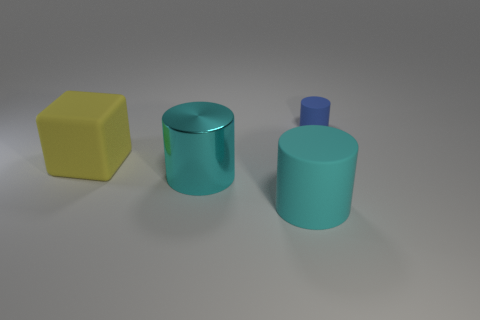Add 2 rubber cylinders. How many objects exist? 6 Subtract all cubes. How many objects are left? 3 Subtract all large cyan matte cylinders. Subtract all big cyan shiny cylinders. How many objects are left? 2 Add 3 tiny blue rubber cylinders. How many tiny blue rubber cylinders are left? 4 Add 4 large metal objects. How many large metal objects exist? 5 Subtract 0 blue spheres. How many objects are left? 4 